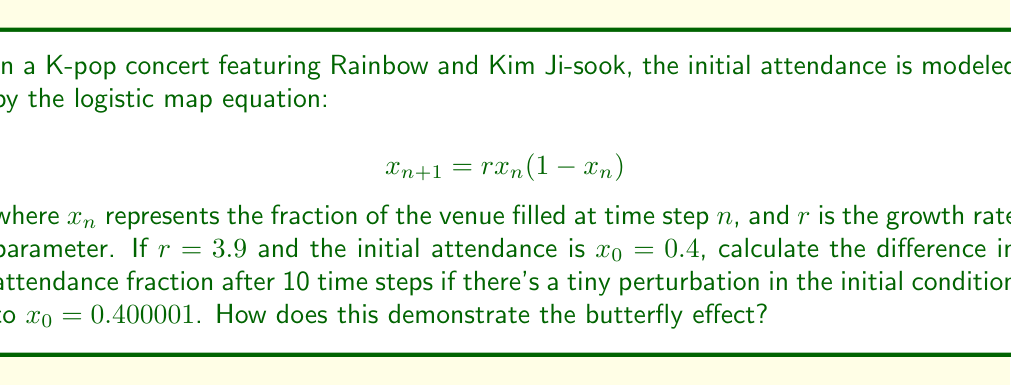Teach me how to tackle this problem. Let's solve this step-by-step:

1) First, we need to iterate the logistic map for both initial conditions:
   $x_0 = 0.4$ and $x_0 = 0.400001$

2) We'll use the equation $x_{n+1} = rx_n(1-x_n)$ with $r = 3.9$

3) For $x_0 = 0.4$:
   $x_1 = 3.9 * 0.4 * (1-0.4) = 0.936$
   $x_2 = 3.9 * 0.936 * (1-0.936) = 0.234144$
   ...
   (continue until $x_{10}$)

4) For $x_0 = 0.400001$:
   $x_1 = 3.9 * 0.400001 * (1-0.400001) = 0.936002339$
   $x_2 = 3.9 * 0.936002339 * (1-0.936002339) = 0.234137225$
   ...
   (continue until $x_{10}$)

5) After 10 iterations:
   For $x_0 = 0.4$: $x_{10} \approx 0.8880$
   For $x_0 = 0.400001$: $x_{10} \approx 0.6708$

6) The difference in attendance fraction after 10 time steps:
   $|0.8880 - 0.6708| \approx 0.2172$

This demonstrates the butterfly effect because a tiny change in the initial condition (0.000001) led to a significant difference in the outcome after just 10 iterations. In the context of concert attendance, this could mean that a small change in initial conditions (like one extra person attending) could lead to drastically different attendance patterns over time.
Answer: 0.2172 